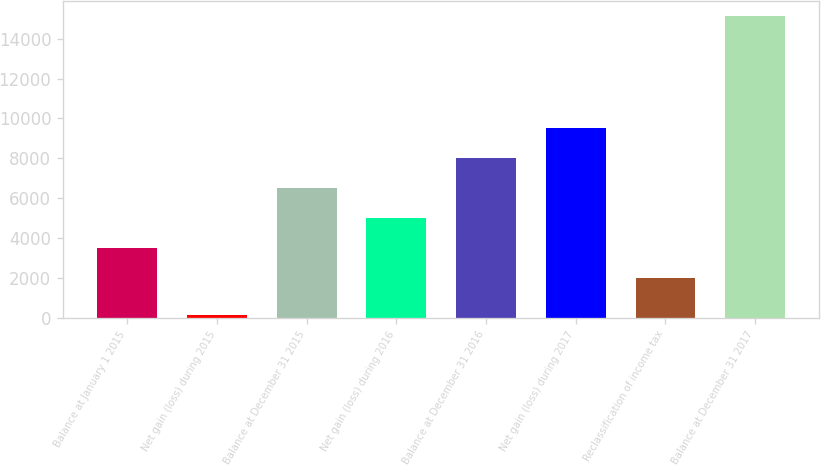Convert chart. <chart><loc_0><loc_0><loc_500><loc_500><bar_chart><fcel>Balance at January 1 2015<fcel>Net gain (loss) during 2015<fcel>Balance at December 31 2015<fcel>Net gain (loss) during 2016<fcel>Balance at December 31 2016<fcel>Net gain (loss) during 2017<fcel>Reclassification of income tax<fcel>Balance at December 31 2017<nl><fcel>3502.9<fcel>129<fcel>6500.7<fcel>5001.8<fcel>7999.6<fcel>9498.5<fcel>2004<fcel>15118<nl></chart> 